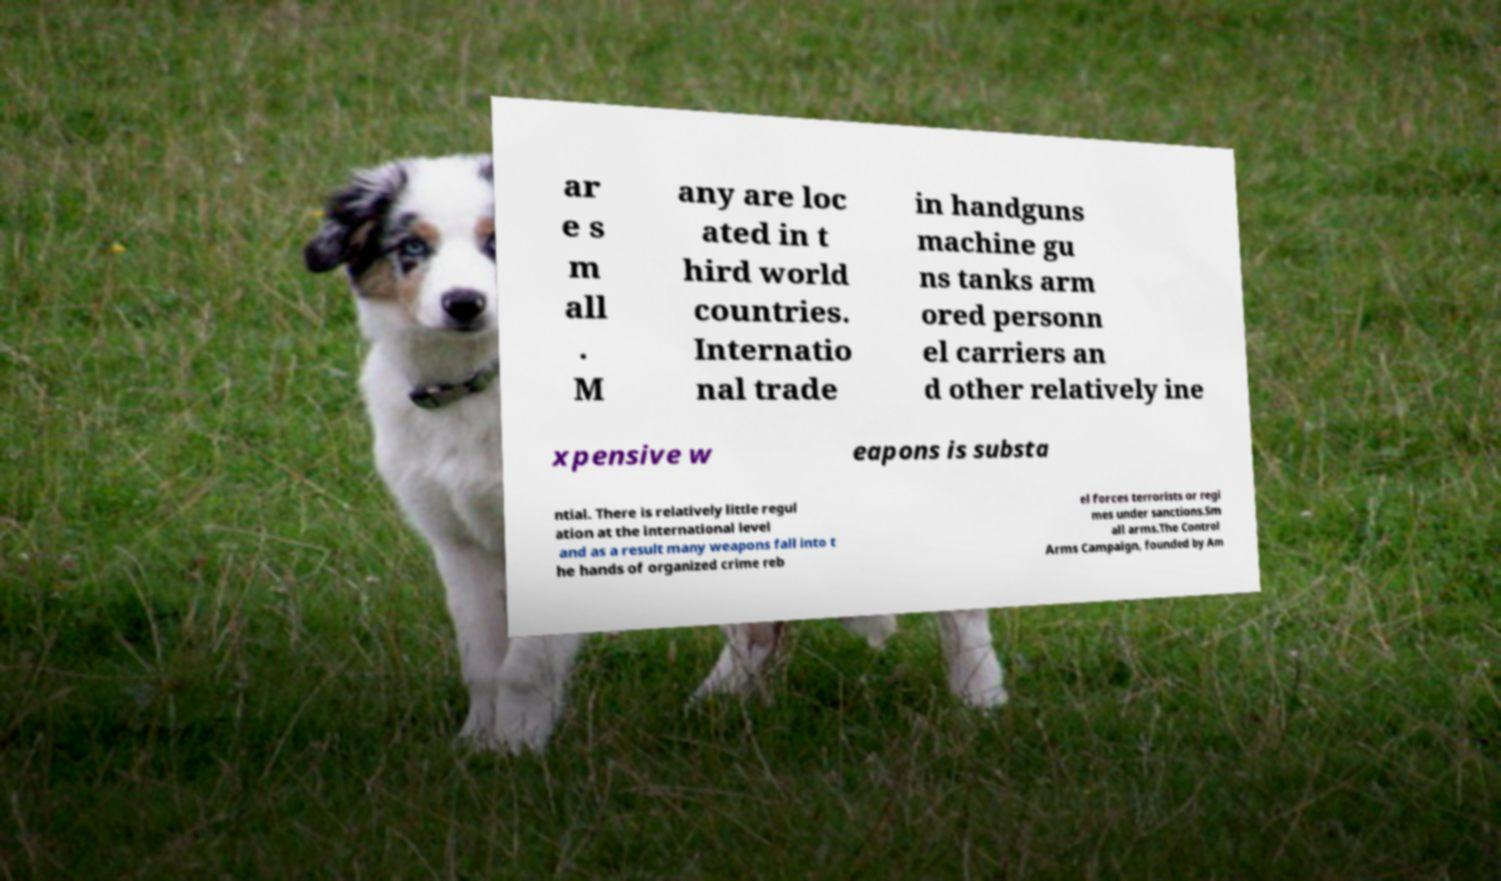There's text embedded in this image that I need extracted. Can you transcribe it verbatim? ar e s m all . M any are loc ated in t hird world countries. Internatio nal trade in handguns machine gu ns tanks arm ored personn el carriers an d other relatively ine xpensive w eapons is substa ntial. There is relatively little regul ation at the international level and as a result many weapons fall into t he hands of organized crime reb el forces terrorists or regi mes under sanctions.Sm all arms.The Control Arms Campaign, founded by Am 